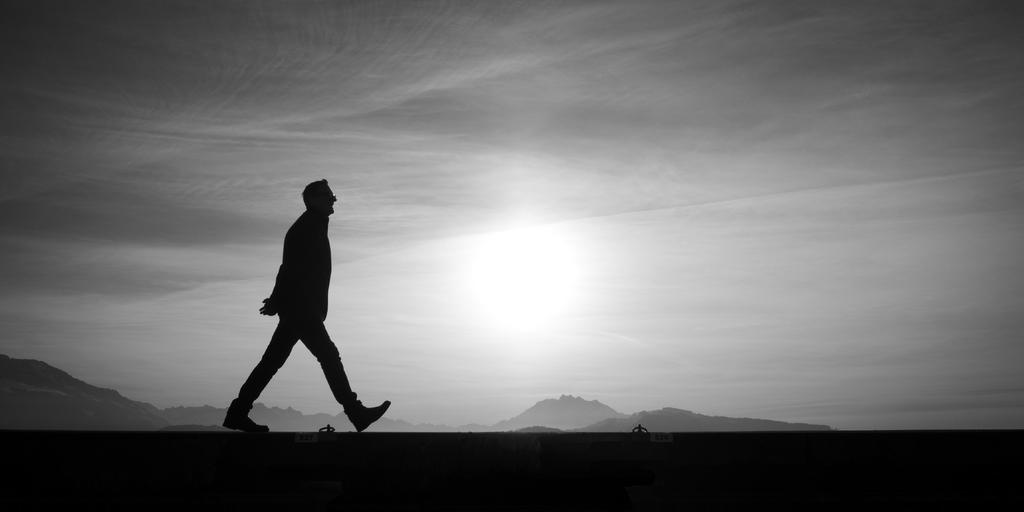What is the color scheme of the image? The image is black and white. What is the man in the image doing? The man is walking in the image. What can be seen in the background of the image? Mountains and the sky are visible in the background of the image. What type of corn can be seen growing in the image? There is no corn present in the image; it features a man walking in a black and white setting with mountains and the sky in the background. Can you tell me how many chess pieces are visible in the image? There are no chess pieces present in the image. 